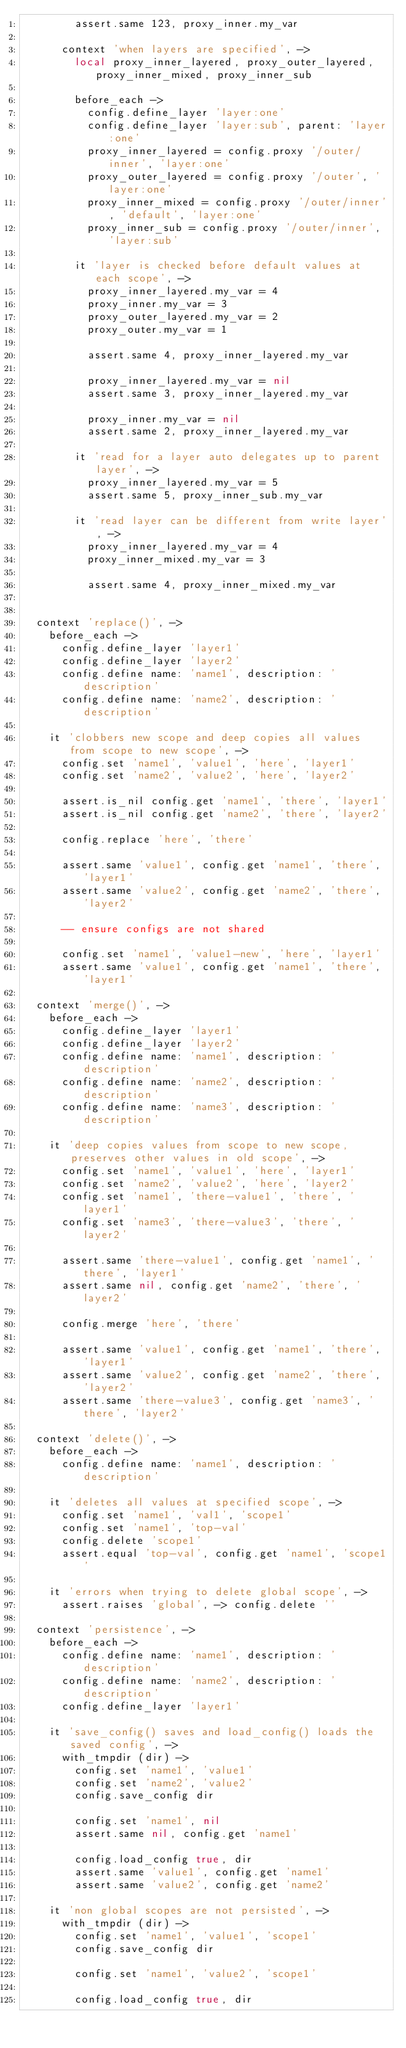<code> <loc_0><loc_0><loc_500><loc_500><_MoonScript_>        assert.same 123, proxy_inner.my_var

      context 'when layers are specified', ->
        local proxy_inner_layered, proxy_outer_layered, proxy_inner_mixed, proxy_inner_sub

        before_each ->
          config.define_layer 'layer:one'
          config.define_layer 'layer:sub', parent: 'layer:one'
          proxy_inner_layered = config.proxy '/outer/inner', 'layer:one'
          proxy_outer_layered = config.proxy '/outer', 'layer:one'
          proxy_inner_mixed = config.proxy '/outer/inner', 'default', 'layer:one'
          proxy_inner_sub = config.proxy '/outer/inner', 'layer:sub'

        it 'layer is checked before default values at each scope', ->
          proxy_inner_layered.my_var = 4
          proxy_inner.my_var = 3
          proxy_outer_layered.my_var = 2
          proxy_outer.my_var = 1

          assert.same 4, proxy_inner_layered.my_var

          proxy_inner_layered.my_var = nil
          assert.same 3, proxy_inner_layered.my_var

          proxy_inner.my_var = nil
          assert.same 2, proxy_inner_layered.my_var

        it 'read for a layer auto delegates up to parent layer', ->
          proxy_inner_layered.my_var = 5
          assert.same 5, proxy_inner_sub.my_var

        it 'read layer can be different from write layer', ->
          proxy_inner_layered.my_var = 4
          proxy_inner_mixed.my_var = 3

          assert.same 4, proxy_inner_mixed.my_var


  context 'replace()', ->
    before_each ->
      config.define_layer 'layer1'
      config.define_layer 'layer2'
      config.define name: 'name1', description: 'description'
      config.define name: 'name2', description: 'description'

    it 'clobbers new scope and deep copies all values from scope to new scope', ->
      config.set 'name1', 'value1', 'here', 'layer1'
      config.set 'name2', 'value2', 'here', 'layer2'

      assert.is_nil config.get 'name1', 'there', 'layer1'
      assert.is_nil config.get 'name2', 'there', 'layer2'

      config.replace 'here', 'there'

      assert.same 'value1', config.get 'name1', 'there', 'layer1'
      assert.same 'value2', config.get 'name2', 'there', 'layer2'

      -- ensure configs are not shared

      config.set 'name1', 'value1-new', 'here', 'layer1'
      assert.same 'value1', config.get 'name1', 'there', 'layer1'

  context 'merge()', ->
    before_each ->
      config.define_layer 'layer1'
      config.define_layer 'layer2'
      config.define name: 'name1', description: 'description'
      config.define name: 'name2', description: 'description'
      config.define name: 'name3', description: 'description'

    it 'deep copies values from scope to new scope, preserves other values in old scope', ->
      config.set 'name1', 'value1', 'here', 'layer1'
      config.set 'name2', 'value2', 'here', 'layer2'
      config.set 'name1', 'there-value1', 'there', 'layer1'
      config.set 'name3', 'there-value3', 'there', 'layer2'

      assert.same 'there-value1', config.get 'name1', 'there', 'layer1'
      assert.same nil, config.get 'name2', 'there', 'layer2'

      config.merge 'here', 'there'

      assert.same 'value1', config.get 'name1', 'there', 'layer1'
      assert.same 'value2', config.get 'name2', 'there', 'layer2'
      assert.same 'there-value3', config.get 'name3', 'there', 'layer2'

  context 'delete()', ->
    before_each ->
      config.define name: 'name1', description: 'description'

    it 'deletes all values at specified scope', ->
      config.set 'name1', 'val1', 'scope1'
      config.set 'name1', 'top-val'
      config.delete 'scope1'
      assert.equal 'top-val', config.get 'name1', 'scope1'

    it 'errors when trying to delete global scope', ->
      assert.raises 'global', -> config.delete ''

  context 'persistence', ->
    before_each ->
      config.define name: 'name1', description: 'description'
      config.define name: 'name2', description: 'description'
      config.define_layer 'layer1'

    it 'save_config() saves and load_config() loads the saved config', ->
      with_tmpdir (dir) ->
        config.set 'name1', 'value1'
        config.set 'name2', 'value2'
        config.save_config dir

        config.set 'name1', nil
        assert.same nil, config.get 'name1'

        config.load_config true, dir
        assert.same 'value1', config.get 'name1'
        assert.same 'value2', config.get 'name2'

    it 'non global scopes are not persisted', ->
      with_tmpdir (dir) ->
        config.set 'name1', 'value1', 'scope1'
        config.save_config dir

        config.set 'name1', 'value2', 'scope1'

        config.load_config true, dir</code> 